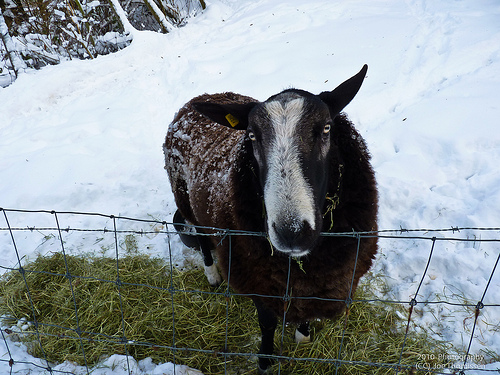<image>
Can you confirm if the animal is in front of the steel fence? No. The animal is not in front of the steel fence. The spatial positioning shows a different relationship between these objects. 